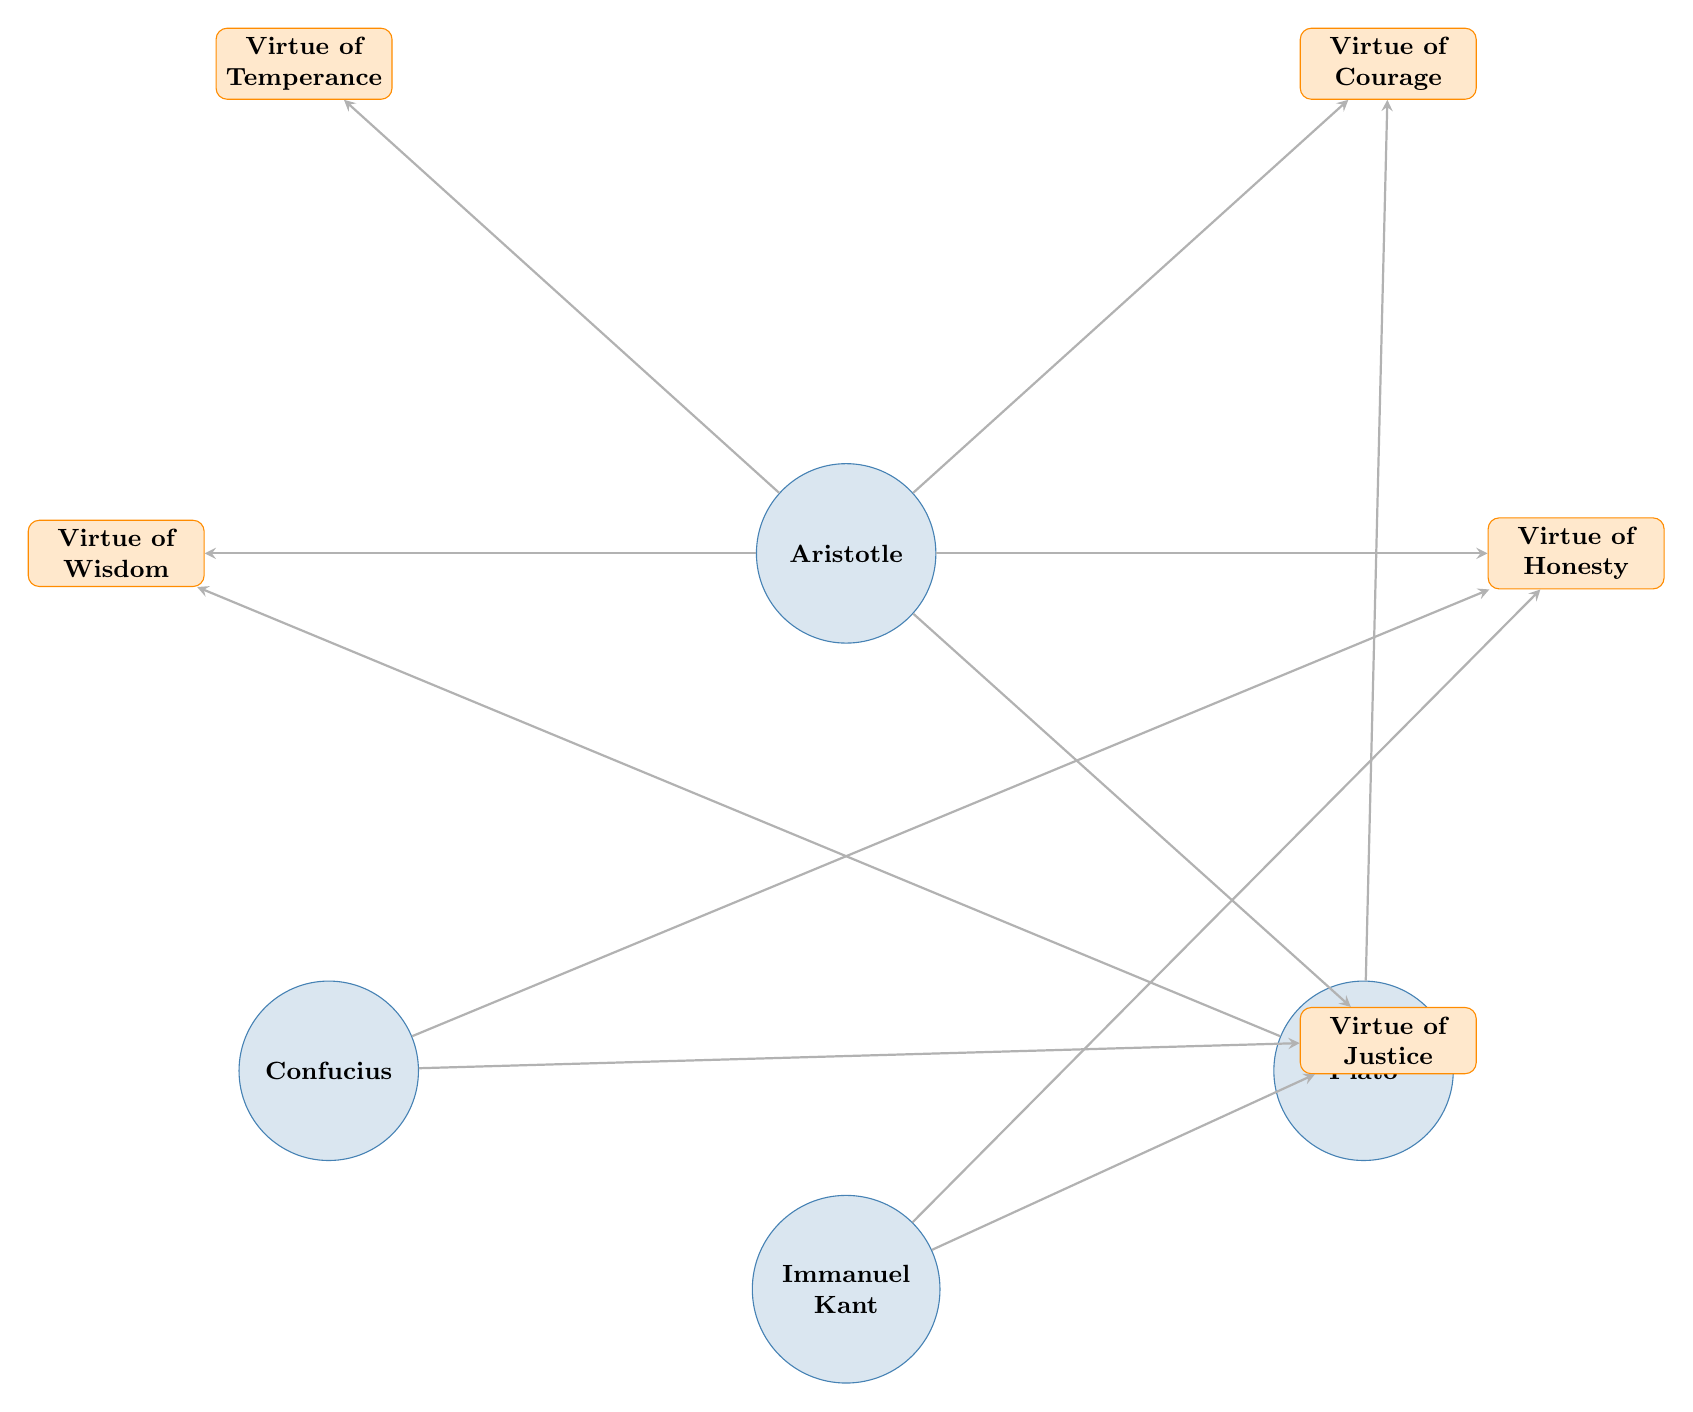What is the total number of philosophers represented in the diagram? The diagram includes four philosophers: Aristotle, Confucius, Plato, and Immanuel Kant. By counting these nodes, we find the total number of philosophers is four.
Answer: 4 Which virtue is linked to both Aristotle and Plato? By examining the connections in the diagram, the virtue of Courage is linked to both Aristotle and Plato through direct connections.
Answer: Virtue of Courage How many total virtues are represented in the diagram? The diagram displays five virtues: Courage, Honesty, Justice, Temperance, and Wisdom. By counting these virtue nodes, we can determine that there are five total virtues represented.
Answer: 5 Which philosopher is associated with the virtue of Honesty? The diagram shows that Honesty is linked to Aristotle, Confucius, and Immanuel Kant, indicating that all three philosophers are associated with this virtue.
Answer: Aristotle, Confucius, and Immanuel Kant How many connections are there in total between philosophers and virtues? The diagram shows ten distinct connections: five from Aristotle to virtues and five split across the others (Confucius, Plato, Kant). Adding these connections gives a total of ten.
Answer: 10 Which virtue is connected solely to Aristotle and not to any other philosopher? By looking at the connections, Virtue of Temperance is linked only to Aristotle and does not have any connections to the other philosophers.
Answer: Virtue of Temperance Which philosopher has the most connections to virtues? Evaluating the connections, Aristotle has five connections to virtues (Courage, Honesty, Justice, Temperance, and Wisdom), while other philosophers have fewer connections. Thus, Aristotle has the most connections.
Answer: Aristotle Which two philosophers share a connection to the Virtue of Justice? The diagram indicates that both Confucius and Immanuel Kant are connected to the Virtue of Justice, as both have direct edges leading to this virtue.
Answer: Confucius and Immanuel Kant 